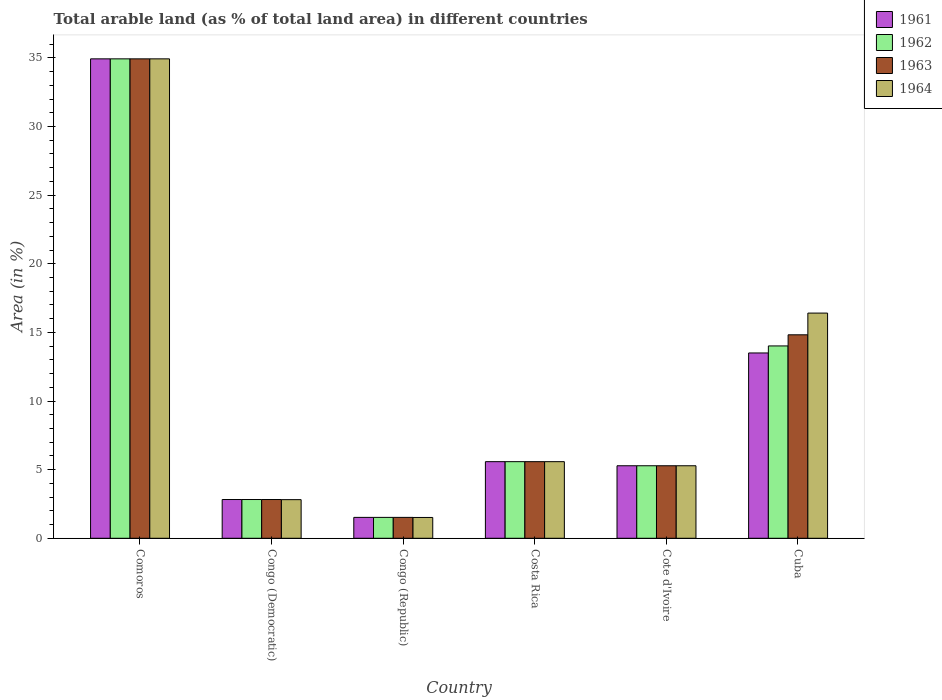How many different coloured bars are there?
Give a very brief answer. 4. How many groups of bars are there?
Your answer should be compact. 6. Are the number of bars on each tick of the X-axis equal?
Offer a very short reply. Yes. How many bars are there on the 5th tick from the left?
Your answer should be compact. 4. How many bars are there on the 6th tick from the right?
Make the answer very short. 4. What is the label of the 6th group of bars from the left?
Your answer should be compact. Cuba. In how many cases, is the number of bars for a given country not equal to the number of legend labels?
Your answer should be very brief. 0. What is the percentage of arable land in 1963 in Costa Rica?
Your answer should be very brief. 5.58. Across all countries, what is the maximum percentage of arable land in 1962?
Your answer should be compact. 34.93. Across all countries, what is the minimum percentage of arable land in 1964?
Offer a terse response. 1.52. In which country was the percentage of arable land in 1962 maximum?
Make the answer very short. Comoros. In which country was the percentage of arable land in 1963 minimum?
Offer a very short reply. Congo (Republic). What is the total percentage of arable land in 1963 in the graph?
Offer a very short reply. 64.96. What is the difference between the percentage of arable land in 1961 in Costa Rica and that in Cuba?
Your answer should be very brief. -7.92. What is the difference between the percentage of arable land in 1961 in Congo (Democratic) and the percentage of arable land in 1962 in Comoros?
Your answer should be compact. -32.1. What is the average percentage of arable land in 1964 per country?
Your answer should be very brief. 11.09. In how many countries, is the percentage of arable land in 1963 greater than 28 %?
Provide a short and direct response. 1. What is the ratio of the percentage of arable land in 1964 in Comoros to that in Cote d'Ivoire?
Keep it short and to the point. 6.61. What is the difference between the highest and the second highest percentage of arable land in 1964?
Offer a terse response. -18.52. What is the difference between the highest and the lowest percentage of arable land in 1961?
Ensure brevity in your answer.  33.4. Is the sum of the percentage of arable land in 1964 in Congo (Democratic) and Cuba greater than the maximum percentage of arable land in 1963 across all countries?
Make the answer very short. No. Is it the case that in every country, the sum of the percentage of arable land in 1961 and percentage of arable land in 1962 is greater than the sum of percentage of arable land in 1964 and percentage of arable land in 1963?
Your answer should be very brief. No. What does the 1st bar from the left in Congo (Republic) represents?
Provide a succinct answer. 1961. Is it the case that in every country, the sum of the percentage of arable land in 1961 and percentage of arable land in 1964 is greater than the percentage of arable land in 1963?
Provide a succinct answer. Yes. How many bars are there?
Make the answer very short. 24. Are all the bars in the graph horizontal?
Offer a terse response. No. How many countries are there in the graph?
Your response must be concise. 6. Does the graph contain any zero values?
Provide a short and direct response. No. Does the graph contain grids?
Offer a very short reply. No. Where does the legend appear in the graph?
Your answer should be very brief. Top right. How many legend labels are there?
Provide a succinct answer. 4. How are the legend labels stacked?
Your answer should be compact. Vertical. What is the title of the graph?
Your response must be concise. Total arable land (as % of total land area) in different countries. Does "1994" appear as one of the legend labels in the graph?
Give a very brief answer. No. What is the label or title of the X-axis?
Provide a succinct answer. Country. What is the label or title of the Y-axis?
Offer a terse response. Area (in %). What is the Area (in %) in 1961 in Comoros?
Provide a succinct answer. 34.93. What is the Area (in %) in 1962 in Comoros?
Provide a short and direct response. 34.93. What is the Area (in %) in 1963 in Comoros?
Make the answer very short. 34.93. What is the Area (in %) in 1964 in Comoros?
Your answer should be very brief. 34.93. What is the Area (in %) of 1961 in Congo (Democratic)?
Provide a succinct answer. 2.82. What is the Area (in %) in 1962 in Congo (Democratic)?
Give a very brief answer. 2.82. What is the Area (in %) of 1963 in Congo (Democratic)?
Provide a succinct answer. 2.82. What is the Area (in %) in 1964 in Congo (Democratic)?
Give a very brief answer. 2.81. What is the Area (in %) of 1961 in Congo (Republic)?
Offer a terse response. 1.52. What is the Area (in %) in 1962 in Congo (Republic)?
Offer a very short reply. 1.52. What is the Area (in %) in 1963 in Congo (Republic)?
Provide a succinct answer. 1.52. What is the Area (in %) of 1964 in Congo (Republic)?
Provide a short and direct response. 1.52. What is the Area (in %) in 1961 in Costa Rica?
Keep it short and to the point. 5.58. What is the Area (in %) of 1962 in Costa Rica?
Ensure brevity in your answer.  5.58. What is the Area (in %) of 1963 in Costa Rica?
Your answer should be very brief. 5.58. What is the Area (in %) in 1964 in Costa Rica?
Ensure brevity in your answer.  5.58. What is the Area (in %) of 1961 in Cote d'Ivoire?
Provide a short and direct response. 5.28. What is the Area (in %) of 1962 in Cote d'Ivoire?
Your answer should be very brief. 5.28. What is the Area (in %) of 1963 in Cote d'Ivoire?
Ensure brevity in your answer.  5.28. What is the Area (in %) in 1964 in Cote d'Ivoire?
Provide a succinct answer. 5.28. What is the Area (in %) of 1961 in Cuba?
Your answer should be compact. 13.5. What is the Area (in %) of 1962 in Cuba?
Your answer should be very brief. 14.01. What is the Area (in %) in 1963 in Cuba?
Your answer should be compact. 14.82. What is the Area (in %) of 1964 in Cuba?
Make the answer very short. 16.41. Across all countries, what is the maximum Area (in %) in 1961?
Your response must be concise. 34.93. Across all countries, what is the maximum Area (in %) of 1962?
Make the answer very short. 34.93. Across all countries, what is the maximum Area (in %) in 1963?
Offer a terse response. 34.93. Across all countries, what is the maximum Area (in %) of 1964?
Your answer should be very brief. 34.93. Across all countries, what is the minimum Area (in %) in 1961?
Provide a short and direct response. 1.52. Across all countries, what is the minimum Area (in %) in 1962?
Provide a short and direct response. 1.52. Across all countries, what is the minimum Area (in %) in 1963?
Your response must be concise. 1.52. Across all countries, what is the minimum Area (in %) in 1964?
Offer a terse response. 1.52. What is the total Area (in %) of 1961 in the graph?
Your answer should be very brief. 63.64. What is the total Area (in %) of 1962 in the graph?
Keep it short and to the point. 64.15. What is the total Area (in %) in 1963 in the graph?
Keep it short and to the point. 64.96. What is the total Area (in %) of 1964 in the graph?
Keep it short and to the point. 66.53. What is the difference between the Area (in %) of 1961 in Comoros and that in Congo (Democratic)?
Your response must be concise. 32.1. What is the difference between the Area (in %) in 1962 in Comoros and that in Congo (Democratic)?
Make the answer very short. 32.1. What is the difference between the Area (in %) in 1963 in Comoros and that in Congo (Democratic)?
Provide a succinct answer. 32.1. What is the difference between the Area (in %) in 1964 in Comoros and that in Congo (Democratic)?
Keep it short and to the point. 32.11. What is the difference between the Area (in %) of 1961 in Comoros and that in Congo (Republic)?
Provide a short and direct response. 33.4. What is the difference between the Area (in %) in 1962 in Comoros and that in Congo (Republic)?
Provide a succinct answer. 33.4. What is the difference between the Area (in %) in 1963 in Comoros and that in Congo (Republic)?
Your response must be concise. 33.4. What is the difference between the Area (in %) in 1964 in Comoros and that in Congo (Republic)?
Offer a terse response. 33.41. What is the difference between the Area (in %) in 1961 in Comoros and that in Costa Rica?
Your response must be concise. 29.35. What is the difference between the Area (in %) of 1962 in Comoros and that in Costa Rica?
Ensure brevity in your answer.  29.35. What is the difference between the Area (in %) in 1963 in Comoros and that in Costa Rica?
Ensure brevity in your answer.  29.35. What is the difference between the Area (in %) in 1964 in Comoros and that in Costa Rica?
Your response must be concise. 29.35. What is the difference between the Area (in %) of 1961 in Comoros and that in Cote d'Ivoire?
Provide a short and direct response. 29.64. What is the difference between the Area (in %) of 1962 in Comoros and that in Cote d'Ivoire?
Provide a succinct answer. 29.64. What is the difference between the Area (in %) of 1963 in Comoros and that in Cote d'Ivoire?
Keep it short and to the point. 29.64. What is the difference between the Area (in %) of 1964 in Comoros and that in Cote d'Ivoire?
Make the answer very short. 29.64. What is the difference between the Area (in %) of 1961 in Comoros and that in Cuba?
Offer a terse response. 21.43. What is the difference between the Area (in %) of 1962 in Comoros and that in Cuba?
Provide a succinct answer. 20.91. What is the difference between the Area (in %) in 1963 in Comoros and that in Cuba?
Your answer should be very brief. 20.1. What is the difference between the Area (in %) in 1964 in Comoros and that in Cuba?
Your response must be concise. 18.52. What is the difference between the Area (in %) in 1961 in Congo (Democratic) and that in Congo (Republic)?
Your response must be concise. 1.3. What is the difference between the Area (in %) of 1962 in Congo (Democratic) and that in Congo (Republic)?
Ensure brevity in your answer.  1.3. What is the difference between the Area (in %) in 1963 in Congo (Democratic) and that in Congo (Republic)?
Offer a terse response. 1.3. What is the difference between the Area (in %) of 1964 in Congo (Democratic) and that in Congo (Republic)?
Provide a short and direct response. 1.3. What is the difference between the Area (in %) in 1961 in Congo (Democratic) and that in Costa Rica?
Keep it short and to the point. -2.76. What is the difference between the Area (in %) in 1962 in Congo (Democratic) and that in Costa Rica?
Your answer should be compact. -2.76. What is the difference between the Area (in %) in 1963 in Congo (Democratic) and that in Costa Rica?
Provide a succinct answer. -2.76. What is the difference between the Area (in %) of 1964 in Congo (Democratic) and that in Costa Rica?
Make the answer very short. -2.77. What is the difference between the Area (in %) in 1961 in Congo (Democratic) and that in Cote d'Ivoire?
Keep it short and to the point. -2.46. What is the difference between the Area (in %) of 1962 in Congo (Democratic) and that in Cote d'Ivoire?
Your answer should be very brief. -2.46. What is the difference between the Area (in %) in 1963 in Congo (Democratic) and that in Cote d'Ivoire?
Give a very brief answer. -2.46. What is the difference between the Area (in %) in 1964 in Congo (Democratic) and that in Cote d'Ivoire?
Offer a terse response. -2.47. What is the difference between the Area (in %) of 1961 in Congo (Democratic) and that in Cuba?
Provide a succinct answer. -10.68. What is the difference between the Area (in %) of 1962 in Congo (Democratic) and that in Cuba?
Provide a short and direct response. -11.19. What is the difference between the Area (in %) in 1964 in Congo (Democratic) and that in Cuba?
Offer a terse response. -13.59. What is the difference between the Area (in %) in 1961 in Congo (Republic) and that in Costa Rica?
Provide a short and direct response. -4.06. What is the difference between the Area (in %) in 1962 in Congo (Republic) and that in Costa Rica?
Provide a succinct answer. -4.06. What is the difference between the Area (in %) of 1963 in Congo (Republic) and that in Costa Rica?
Offer a very short reply. -4.06. What is the difference between the Area (in %) of 1964 in Congo (Republic) and that in Costa Rica?
Your answer should be very brief. -4.06. What is the difference between the Area (in %) of 1961 in Congo (Republic) and that in Cote d'Ivoire?
Your answer should be very brief. -3.76. What is the difference between the Area (in %) of 1962 in Congo (Republic) and that in Cote d'Ivoire?
Provide a short and direct response. -3.76. What is the difference between the Area (in %) in 1963 in Congo (Republic) and that in Cote d'Ivoire?
Give a very brief answer. -3.76. What is the difference between the Area (in %) in 1964 in Congo (Republic) and that in Cote d'Ivoire?
Keep it short and to the point. -3.77. What is the difference between the Area (in %) in 1961 in Congo (Republic) and that in Cuba?
Give a very brief answer. -11.98. What is the difference between the Area (in %) of 1962 in Congo (Republic) and that in Cuba?
Your answer should be very brief. -12.49. What is the difference between the Area (in %) of 1963 in Congo (Republic) and that in Cuba?
Keep it short and to the point. -13.3. What is the difference between the Area (in %) in 1964 in Congo (Republic) and that in Cuba?
Keep it short and to the point. -14.89. What is the difference between the Area (in %) of 1961 in Costa Rica and that in Cote d'Ivoire?
Your answer should be compact. 0.3. What is the difference between the Area (in %) in 1962 in Costa Rica and that in Cote d'Ivoire?
Offer a terse response. 0.3. What is the difference between the Area (in %) of 1963 in Costa Rica and that in Cote d'Ivoire?
Keep it short and to the point. 0.3. What is the difference between the Area (in %) in 1964 in Costa Rica and that in Cote d'Ivoire?
Ensure brevity in your answer.  0.3. What is the difference between the Area (in %) of 1961 in Costa Rica and that in Cuba?
Offer a terse response. -7.92. What is the difference between the Area (in %) of 1962 in Costa Rica and that in Cuba?
Keep it short and to the point. -8.43. What is the difference between the Area (in %) in 1963 in Costa Rica and that in Cuba?
Provide a succinct answer. -9.24. What is the difference between the Area (in %) in 1964 in Costa Rica and that in Cuba?
Your answer should be very brief. -10.82. What is the difference between the Area (in %) of 1961 in Cote d'Ivoire and that in Cuba?
Give a very brief answer. -8.22. What is the difference between the Area (in %) in 1962 in Cote d'Ivoire and that in Cuba?
Your answer should be very brief. -8.73. What is the difference between the Area (in %) in 1963 in Cote d'Ivoire and that in Cuba?
Offer a very short reply. -9.54. What is the difference between the Area (in %) of 1964 in Cote d'Ivoire and that in Cuba?
Make the answer very short. -11.12. What is the difference between the Area (in %) in 1961 in Comoros and the Area (in %) in 1962 in Congo (Democratic)?
Keep it short and to the point. 32.1. What is the difference between the Area (in %) in 1961 in Comoros and the Area (in %) in 1963 in Congo (Democratic)?
Your answer should be compact. 32.1. What is the difference between the Area (in %) in 1961 in Comoros and the Area (in %) in 1964 in Congo (Democratic)?
Ensure brevity in your answer.  32.11. What is the difference between the Area (in %) in 1962 in Comoros and the Area (in %) in 1963 in Congo (Democratic)?
Provide a succinct answer. 32.1. What is the difference between the Area (in %) of 1962 in Comoros and the Area (in %) of 1964 in Congo (Democratic)?
Your answer should be very brief. 32.11. What is the difference between the Area (in %) of 1963 in Comoros and the Area (in %) of 1964 in Congo (Democratic)?
Provide a short and direct response. 32.11. What is the difference between the Area (in %) in 1961 in Comoros and the Area (in %) in 1962 in Congo (Republic)?
Your response must be concise. 33.4. What is the difference between the Area (in %) of 1961 in Comoros and the Area (in %) of 1963 in Congo (Republic)?
Provide a succinct answer. 33.4. What is the difference between the Area (in %) in 1961 in Comoros and the Area (in %) in 1964 in Congo (Republic)?
Your answer should be compact. 33.41. What is the difference between the Area (in %) of 1962 in Comoros and the Area (in %) of 1963 in Congo (Republic)?
Offer a terse response. 33.4. What is the difference between the Area (in %) in 1962 in Comoros and the Area (in %) in 1964 in Congo (Republic)?
Provide a succinct answer. 33.41. What is the difference between the Area (in %) in 1963 in Comoros and the Area (in %) in 1964 in Congo (Republic)?
Provide a succinct answer. 33.41. What is the difference between the Area (in %) of 1961 in Comoros and the Area (in %) of 1962 in Costa Rica?
Provide a short and direct response. 29.35. What is the difference between the Area (in %) in 1961 in Comoros and the Area (in %) in 1963 in Costa Rica?
Offer a terse response. 29.35. What is the difference between the Area (in %) of 1961 in Comoros and the Area (in %) of 1964 in Costa Rica?
Ensure brevity in your answer.  29.35. What is the difference between the Area (in %) of 1962 in Comoros and the Area (in %) of 1963 in Costa Rica?
Offer a terse response. 29.35. What is the difference between the Area (in %) of 1962 in Comoros and the Area (in %) of 1964 in Costa Rica?
Provide a short and direct response. 29.35. What is the difference between the Area (in %) in 1963 in Comoros and the Area (in %) in 1964 in Costa Rica?
Ensure brevity in your answer.  29.35. What is the difference between the Area (in %) of 1961 in Comoros and the Area (in %) of 1962 in Cote d'Ivoire?
Your answer should be very brief. 29.64. What is the difference between the Area (in %) of 1961 in Comoros and the Area (in %) of 1963 in Cote d'Ivoire?
Provide a short and direct response. 29.64. What is the difference between the Area (in %) in 1961 in Comoros and the Area (in %) in 1964 in Cote d'Ivoire?
Make the answer very short. 29.64. What is the difference between the Area (in %) in 1962 in Comoros and the Area (in %) in 1963 in Cote d'Ivoire?
Keep it short and to the point. 29.64. What is the difference between the Area (in %) of 1962 in Comoros and the Area (in %) of 1964 in Cote d'Ivoire?
Offer a terse response. 29.64. What is the difference between the Area (in %) in 1963 in Comoros and the Area (in %) in 1964 in Cote d'Ivoire?
Offer a terse response. 29.64. What is the difference between the Area (in %) of 1961 in Comoros and the Area (in %) of 1962 in Cuba?
Offer a very short reply. 20.91. What is the difference between the Area (in %) in 1961 in Comoros and the Area (in %) in 1963 in Cuba?
Your answer should be very brief. 20.1. What is the difference between the Area (in %) of 1961 in Comoros and the Area (in %) of 1964 in Cuba?
Offer a terse response. 18.52. What is the difference between the Area (in %) in 1962 in Comoros and the Area (in %) in 1963 in Cuba?
Keep it short and to the point. 20.1. What is the difference between the Area (in %) in 1962 in Comoros and the Area (in %) in 1964 in Cuba?
Provide a short and direct response. 18.52. What is the difference between the Area (in %) of 1963 in Comoros and the Area (in %) of 1964 in Cuba?
Make the answer very short. 18.52. What is the difference between the Area (in %) of 1961 in Congo (Democratic) and the Area (in %) of 1962 in Congo (Republic)?
Your answer should be very brief. 1.3. What is the difference between the Area (in %) of 1961 in Congo (Democratic) and the Area (in %) of 1963 in Congo (Republic)?
Give a very brief answer. 1.3. What is the difference between the Area (in %) of 1961 in Congo (Democratic) and the Area (in %) of 1964 in Congo (Republic)?
Give a very brief answer. 1.31. What is the difference between the Area (in %) of 1962 in Congo (Democratic) and the Area (in %) of 1963 in Congo (Republic)?
Keep it short and to the point. 1.3. What is the difference between the Area (in %) of 1962 in Congo (Democratic) and the Area (in %) of 1964 in Congo (Republic)?
Make the answer very short. 1.31. What is the difference between the Area (in %) in 1963 in Congo (Democratic) and the Area (in %) in 1964 in Congo (Republic)?
Provide a short and direct response. 1.31. What is the difference between the Area (in %) in 1961 in Congo (Democratic) and the Area (in %) in 1962 in Costa Rica?
Your answer should be very brief. -2.76. What is the difference between the Area (in %) in 1961 in Congo (Democratic) and the Area (in %) in 1963 in Costa Rica?
Make the answer very short. -2.76. What is the difference between the Area (in %) of 1961 in Congo (Democratic) and the Area (in %) of 1964 in Costa Rica?
Your response must be concise. -2.76. What is the difference between the Area (in %) in 1962 in Congo (Democratic) and the Area (in %) in 1963 in Costa Rica?
Offer a very short reply. -2.76. What is the difference between the Area (in %) of 1962 in Congo (Democratic) and the Area (in %) of 1964 in Costa Rica?
Make the answer very short. -2.76. What is the difference between the Area (in %) in 1963 in Congo (Democratic) and the Area (in %) in 1964 in Costa Rica?
Your answer should be very brief. -2.76. What is the difference between the Area (in %) of 1961 in Congo (Democratic) and the Area (in %) of 1962 in Cote d'Ivoire?
Your answer should be very brief. -2.46. What is the difference between the Area (in %) in 1961 in Congo (Democratic) and the Area (in %) in 1963 in Cote d'Ivoire?
Your response must be concise. -2.46. What is the difference between the Area (in %) in 1961 in Congo (Democratic) and the Area (in %) in 1964 in Cote d'Ivoire?
Offer a very short reply. -2.46. What is the difference between the Area (in %) of 1962 in Congo (Democratic) and the Area (in %) of 1963 in Cote d'Ivoire?
Your response must be concise. -2.46. What is the difference between the Area (in %) of 1962 in Congo (Democratic) and the Area (in %) of 1964 in Cote d'Ivoire?
Provide a short and direct response. -2.46. What is the difference between the Area (in %) of 1963 in Congo (Democratic) and the Area (in %) of 1964 in Cote d'Ivoire?
Make the answer very short. -2.46. What is the difference between the Area (in %) of 1961 in Congo (Democratic) and the Area (in %) of 1962 in Cuba?
Offer a very short reply. -11.19. What is the difference between the Area (in %) in 1961 in Congo (Democratic) and the Area (in %) in 1963 in Cuba?
Your response must be concise. -12. What is the difference between the Area (in %) in 1961 in Congo (Democratic) and the Area (in %) in 1964 in Cuba?
Offer a very short reply. -13.58. What is the difference between the Area (in %) of 1962 in Congo (Democratic) and the Area (in %) of 1964 in Cuba?
Offer a very short reply. -13.58. What is the difference between the Area (in %) in 1963 in Congo (Democratic) and the Area (in %) in 1964 in Cuba?
Ensure brevity in your answer.  -13.58. What is the difference between the Area (in %) of 1961 in Congo (Republic) and the Area (in %) of 1962 in Costa Rica?
Offer a very short reply. -4.06. What is the difference between the Area (in %) of 1961 in Congo (Republic) and the Area (in %) of 1963 in Costa Rica?
Your answer should be very brief. -4.06. What is the difference between the Area (in %) in 1961 in Congo (Republic) and the Area (in %) in 1964 in Costa Rica?
Offer a very short reply. -4.06. What is the difference between the Area (in %) in 1962 in Congo (Republic) and the Area (in %) in 1963 in Costa Rica?
Make the answer very short. -4.06. What is the difference between the Area (in %) of 1962 in Congo (Republic) and the Area (in %) of 1964 in Costa Rica?
Ensure brevity in your answer.  -4.06. What is the difference between the Area (in %) of 1963 in Congo (Republic) and the Area (in %) of 1964 in Costa Rica?
Your answer should be compact. -4.06. What is the difference between the Area (in %) in 1961 in Congo (Republic) and the Area (in %) in 1962 in Cote d'Ivoire?
Your answer should be very brief. -3.76. What is the difference between the Area (in %) of 1961 in Congo (Republic) and the Area (in %) of 1963 in Cote d'Ivoire?
Offer a very short reply. -3.76. What is the difference between the Area (in %) of 1961 in Congo (Republic) and the Area (in %) of 1964 in Cote d'Ivoire?
Keep it short and to the point. -3.76. What is the difference between the Area (in %) of 1962 in Congo (Republic) and the Area (in %) of 1963 in Cote d'Ivoire?
Your answer should be very brief. -3.76. What is the difference between the Area (in %) of 1962 in Congo (Republic) and the Area (in %) of 1964 in Cote d'Ivoire?
Your answer should be very brief. -3.76. What is the difference between the Area (in %) of 1963 in Congo (Republic) and the Area (in %) of 1964 in Cote d'Ivoire?
Give a very brief answer. -3.76. What is the difference between the Area (in %) of 1961 in Congo (Republic) and the Area (in %) of 1962 in Cuba?
Keep it short and to the point. -12.49. What is the difference between the Area (in %) in 1961 in Congo (Republic) and the Area (in %) in 1963 in Cuba?
Keep it short and to the point. -13.3. What is the difference between the Area (in %) of 1961 in Congo (Republic) and the Area (in %) of 1964 in Cuba?
Give a very brief answer. -14.88. What is the difference between the Area (in %) of 1962 in Congo (Republic) and the Area (in %) of 1963 in Cuba?
Your response must be concise. -13.3. What is the difference between the Area (in %) in 1962 in Congo (Republic) and the Area (in %) in 1964 in Cuba?
Your answer should be very brief. -14.88. What is the difference between the Area (in %) in 1963 in Congo (Republic) and the Area (in %) in 1964 in Cuba?
Offer a very short reply. -14.88. What is the difference between the Area (in %) of 1961 in Costa Rica and the Area (in %) of 1962 in Cote d'Ivoire?
Provide a succinct answer. 0.3. What is the difference between the Area (in %) of 1961 in Costa Rica and the Area (in %) of 1963 in Cote d'Ivoire?
Make the answer very short. 0.3. What is the difference between the Area (in %) in 1961 in Costa Rica and the Area (in %) in 1964 in Cote d'Ivoire?
Your answer should be compact. 0.3. What is the difference between the Area (in %) of 1962 in Costa Rica and the Area (in %) of 1963 in Cote d'Ivoire?
Offer a very short reply. 0.3. What is the difference between the Area (in %) of 1962 in Costa Rica and the Area (in %) of 1964 in Cote d'Ivoire?
Give a very brief answer. 0.3. What is the difference between the Area (in %) in 1963 in Costa Rica and the Area (in %) in 1964 in Cote d'Ivoire?
Make the answer very short. 0.3. What is the difference between the Area (in %) of 1961 in Costa Rica and the Area (in %) of 1962 in Cuba?
Provide a succinct answer. -8.43. What is the difference between the Area (in %) of 1961 in Costa Rica and the Area (in %) of 1963 in Cuba?
Offer a terse response. -9.24. What is the difference between the Area (in %) in 1961 in Costa Rica and the Area (in %) in 1964 in Cuba?
Your answer should be very brief. -10.82. What is the difference between the Area (in %) in 1962 in Costa Rica and the Area (in %) in 1963 in Cuba?
Keep it short and to the point. -9.24. What is the difference between the Area (in %) in 1962 in Costa Rica and the Area (in %) in 1964 in Cuba?
Offer a terse response. -10.82. What is the difference between the Area (in %) of 1963 in Costa Rica and the Area (in %) of 1964 in Cuba?
Offer a very short reply. -10.82. What is the difference between the Area (in %) in 1961 in Cote d'Ivoire and the Area (in %) in 1962 in Cuba?
Offer a very short reply. -8.73. What is the difference between the Area (in %) of 1961 in Cote d'Ivoire and the Area (in %) of 1963 in Cuba?
Your answer should be very brief. -9.54. What is the difference between the Area (in %) of 1961 in Cote d'Ivoire and the Area (in %) of 1964 in Cuba?
Your answer should be compact. -11.12. What is the difference between the Area (in %) in 1962 in Cote d'Ivoire and the Area (in %) in 1963 in Cuba?
Your response must be concise. -9.54. What is the difference between the Area (in %) in 1962 in Cote d'Ivoire and the Area (in %) in 1964 in Cuba?
Your answer should be very brief. -11.12. What is the difference between the Area (in %) in 1963 in Cote d'Ivoire and the Area (in %) in 1964 in Cuba?
Your answer should be compact. -11.12. What is the average Area (in %) in 1961 per country?
Your response must be concise. 10.61. What is the average Area (in %) of 1962 per country?
Your response must be concise. 10.69. What is the average Area (in %) in 1963 per country?
Provide a short and direct response. 10.83. What is the average Area (in %) in 1964 per country?
Your response must be concise. 11.09. What is the difference between the Area (in %) of 1961 and Area (in %) of 1962 in Comoros?
Keep it short and to the point. 0. What is the difference between the Area (in %) in 1961 and Area (in %) in 1964 in Congo (Democratic)?
Your answer should be compact. 0.01. What is the difference between the Area (in %) of 1962 and Area (in %) of 1963 in Congo (Democratic)?
Your answer should be very brief. 0. What is the difference between the Area (in %) in 1962 and Area (in %) in 1964 in Congo (Democratic)?
Give a very brief answer. 0.01. What is the difference between the Area (in %) in 1963 and Area (in %) in 1964 in Congo (Democratic)?
Your response must be concise. 0.01. What is the difference between the Area (in %) in 1961 and Area (in %) in 1962 in Congo (Republic)?
Offer a very short reply. 0. What is the difference between the Area (in %) of 1961 and Area (in %) of 1964 in Congo (Republic)?
Your response must be concise. 0.01. What is the difference between the Area (in %) of 1962 and Area (in %) of 1964 in Congo (Republic)?
Your answer should be very brief. 0.01. What is the difference between the Area (in %) of 1963 and Area (in %) of 1964 in Congo (Republic)?
Offer a terse response. 0.01. What is the difference between the Area (in %) of 1961 and Area (in %) of 1963 in Costa Rica?
Offer a very short reply. 0. What is the difference between the Area (in %) in 1961 and Area (in %) in 1964 in Costa Rica?
Offer a very short reply. 0. What is the difference between the Area (in %) in 1963 and Area (in %) in 1964 in Costa Rica?
Give a very brief answer. 0. What is the difference between the Area (in %) in 1961 and Area (in %) in 1963 in Cote d'Ivoire?
Make the answer very short. 0. What is the difference between the Area (in %) in 1962 and Area (in %) in 1964 in Cote d'Ivoire?
Give a very brief answer. 0. What is the difference between the Area (in %) in 1961 and Area (in %) in 1962 in Cuba?
Your answer should be compact. -0.51. What is the difference between the Area (in %) of 1961 and Area (in %) of 1963 in Cuba?
Keep it short and to the point. -1.32. What is the difference between the Area (in %) in 1961 and Area (in %) in 1964 in Cuba?
Provide a succinct answer. -2.9. What is the difference between the Area (in %) in 1962 and Area (in %) in 1963 in Cuba?
Keep it short and to the point. -0.81. What is the difference between the Area (in %) of 1962 and Area (in %) of 1964 in Cuba?
Provide a short and direct response. -2.39. What is the difference between the Area (in %) in 1963 and Area (in %) in 1964 in Cuba?
Offer a terse response. -1.58. What is the ratio of the Area (in %) of 1961 in Comoros to that in Congo (Democratic)?
Your response must be concise. 12.37. What is the ratio of the Area (in %) in 1962 in Comoros to that in Congo (Democratic)?
Provide a succinct answer. 12.37. What is the ratio of the Area (in %) of 1963 in Comoros to that in Congo (Democratic)?
Give a very brief answer. 12.37. What is the ratio of the Area (in %) in 1964 in Comoros to that in Congo (Democratic)?
Give a very brief answer. 12.41. What is the ratio of the Area (in %) in 1961 in Comoros to that in Congo (Republic)?
Your answer should be compact. 22.94. What is the ratio of the Area (in %) in 1962 in Comoros to that in Congo (Republic)?
Keep it short and to the point. 22.94. What is the ratio of the Area (in %) in 1963 in Comoros to that in Congo (Republic)?
Provide a short and direct response. 22.94. What is the ratio of the Area (in %) of 1964 in Comoros to that in Congo (Republic)?
Give a very brief answer. 23.03. What is the ratio of the Area (in %) of 1961 in Comoros to that in Costa Rica?
Keep it short and to the point. 6.26. What is the ratio of the Area (in %) in 1962 in Comoros to that in Costa Rica?
Make the answer very short. 6.26. What is the ratio of the Area (in %) in 1963 in Comoros to that in Costa Rica?
Offer a terse response. 6.26. What is the ratio of the Area (in %) in 1964 in Comoros to that in Costa Rica?
Ensure brevity in your answer.  6.26. What is the ratio of the Area (in %) of 1961 in Comoros to that in Cote d'Ivoire?
Make the answer very short. 6.61. What is the ratio of the Area (in %) of 1962 in Comoros to that in Cote d'Ivoire?
Your answer should be very brief. 6.61. What is the ratio of the Area (in %) in 1963 in Comoros to that in Cote d'Ivoire?
Provide a succinct answer. 6.61. What is the ratio of the Area (in %) of 1964 in Comoros to that in Cote d'Ivoire?
Your answer should be very brief. 6.61. What is the ratio of the Area (in %) of 1961 in Comoros to that in Cuba?
Your answer should be very brief. 2.59. What is the ratio of the Area (in %) in 1962 in Comoros to that in Cuba?
Offer a terse response. 2.49. What is the ratio of the Area (in %) of 1963 in Comoros to that in Cuba?
Give a very brief answer. 2.36. What is the ratio of the Area (in %) in 1964 in Comoros to that in Cuba?
Your response must be concise. 2.13. What is the ratio of the Area (in %) of 1961 in Congo (Democratic) to that in Congo (Republic)?
Keep it short and to the point. 1.85. What is the ratio of the Area (in %) in 1962 in Congo (Democratic) to that in Congo (Republic)?
Offer a very short reply. 1.85. What is the ratio of the Area (in %) of 1963 in Congo (Democratic) to that in Congo (Republic)?
Make the answer very short. 1.85. What is the ratio of the Area (in %) in 1964 in Congo (Democratic) to that in Congo (Republic)?
Offer a terse response. 1.86. What is the ratio of the Area (in %) of 1961 in Congo (Democratic) to that in Costa Rica?
Your response must be concise. 0.51. What is the ratio of the Area (in %) in 1962 in Congo (Democratic) to that in Costa Rica?
Keep it short and to the point. 0.51. What is the ratio of the Area (in %) of 1963 in Congo (Democratic) to that in Costa Rica?
Make the answer very short. 0.51. What is the ratio of the Area (in %) in 1964 in Congo (Democratic) to that in Costa Rica?
Offer a terse response. 0.5. What is the ratio of the Area (in %) of 1961 in Congo (Democratic) to that in Cote d'Ivoire?
Your answer should be compact. 0.53. What is the ratio of the Area (in %) of 1962 in Congo (Democratic) to that in Cote d'Ivoire?
Make the answer very short. 0.53. What is the ratio of the Area (in %) of 1963 in Congo (Democratic) to that in Cote d'Ivoire?
Your answer should be very brief. 0.53. What is the ratio of the Area (in %) of 1964 in Congo (Democratic) to that in Cote d'Ivoire?
Ensure brevity in your answer.  0.53. What is the ratio of the Area (in %) in 1961 in Congo (Democratic) to that in Cuba?
Your answer should be very brief. 0.21. What is the ratio of the Area (in %) of 1962 in Congo (Democratic) to that in Cuba?
Keep it short and to the point. 0.2. What is the ratio of the Area (in %) in 1963 in Congo (Democratic) to that in Cuba?
Keep it short and to the point. 0.19. What is the ratio of the Area (in %) of 1964 in Congo (Democratic) to that in Cuba?
Make the answer very short. 0.17. What is the ratio of the Area (in %) in 1961 in Congo (Republic) to that in Costa Rica?
Your response must be concise. 0.27. What is the ratio of the Area (in %) in 1962 in Congo (Republic) to that in Costa Rica?
Your answer should be compact. 0.27. What is the ratio of the Area (in %) of 1963 in Congo (Republic) to that in Costa Rica?
Provide a succinct answer. 0.27. What is the ratio of the Area (in %) of 1964 in Congo (Republic) to that in Costa Rica?
Your answer should be very brief. 0.27. What is the ratio of the Area (in %) in 1961 in Congo (Republic) to that in Cote d'Ivoire?
Make the answer very short. 0.29. What is the ratio of the Area (in %) in 1962 in Congo (Republic) to that in Cote d'Ivoire?
Give a very brief answer. 0.29. What is the ratio of the Area (in %) in 1963 in Congo (Republic) to that in Cote d'Ivoire?
Your response must be concise. 0.29. What is the ratio of the Area (in %) of 1964 in Congo (Republic) to that in Cote d'Ivoire?
Ensure brevity in your answer.  0.29. What is the ratio of the Area (in %) of 1961 in Congo (Republic) to that in Cuba?
Give a very brief answer. 0.11. What is the ratio of the Area (in %) in 1962 in Congo (Republic) to that in Cuba?
Offer a very short reply. 0.11. What is the ratio of the Area (in %) in 1963 in Congo (Republic) to that in Cuba?
Keep it short and to the point. 0.1. What is the ratio of the Area (in %) in 1964 in Congo (Republic) to that in Cuba?
Your response must be concise. 0.09. What is the ratio of the Area (in %) of 1961 in Costa Rica to that in Cote d'Ivoire?
Provide a succinct answer. 1.06. What is the ratio of the Area (in %) of 1962 in Costa Rica to that in Cote d'Ivoire?
Your response must be concise. 1.06. What is the ratio of the Area (in %) of 1963 in Costa Rica to that in Cote d'Ivoire?
Ensure brevity in your answer.  1.06. What is the ratio of the Area (in %) in 1964 in Costa Rica to that in Cote d'Ivoire?
Your answer should be very brief. 1.06. What is the ratio of the Area (in %) in 1961 in Costa Rica to that in Cuba?
Your answer should be very brief. 0.41. What is the ratio of the Area (in %) in 1962 in Costa Rica to that in Cuba?
Offer a very short reply. 0.4. What is the ratio of the Area (in %) in 1963 in Costa Rica to that in Cuba?
Offer a very short reply. 0.38. What is the ratio of the Area (in %) in 1964 in Costa Rica to that in Cuba?
Offer a terse response. 0.34. What is the ratio of the Area (in %) in 1961 in Cote d'Ivoire to that in Cuba?
Give a very brief answer. 0.39. What is the ratio of the Area (in %) of 1962 in Cote d'Ivoire to that in Cuba?
Provide a short and direct response. 0.38. What is the ratio of the Area (in %) in 1963 in Cote d'Ivoire to that in Cuba?
Provide a succinct answer. 0.36. What is the ratio of the Area (in %) of 1964 in Cote d'Ivoire to that in Cuba?
Keep it short and to the point. 0.32. What is the difference between the highest and the second highest Area (in %) of 1961?
Ensure brevity in your answer.  21.43. What is the difference between the highest and the second highest Area (in %) of 1962?
Ensure brevity in your answer.  20.91. What is the difference between the highest and the second highest Area (in %) in 1963?
Provide a succinct answer. 20.1. What is the difference between the highest and the second highest Area (in %) of 1964?
Offer a terse response. 18.52. What is the difference between the highest and the lowest Area (in %) of 1961?
Give a very brief answer. 33.4. What is the difference between the highest and the lowest Area (in %) in 1962?
Give a very brief answer. 33.4. What is the difference between the highest and the lowest Area (in %) in 1963?
Ensure brevity in your answer.  33.4. What is the difference between the highest and the lowest Area (in %) in 1964?
Provide a short and direct response. 33.41. 